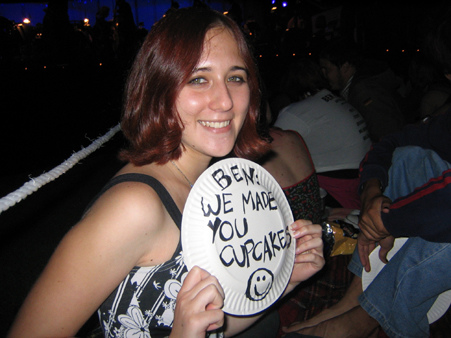<image>
Is the paper plate to the right of the girl? No. The paper plate is not to the right of the girl. The horizontal positioning shows a different relationship. 